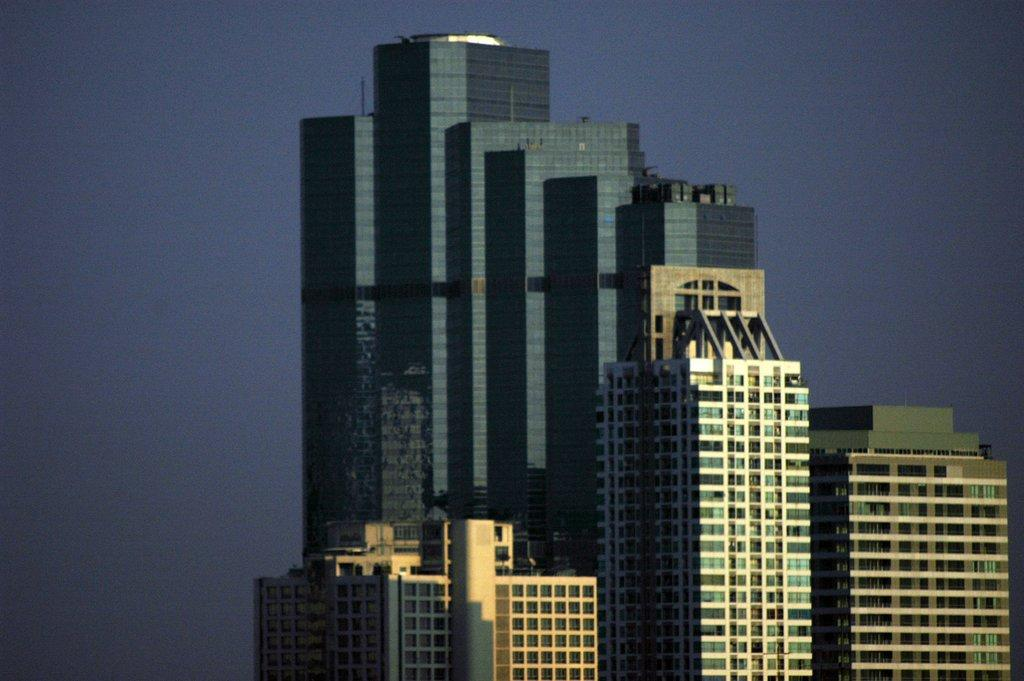What is the main feature of the image? The main feature of the image is many tall towers. What other structures can be seen in the image? There are buildings in the image. Can you touch the thought in the image? There is no thought present in the image, and therefore it cannot be touched. 